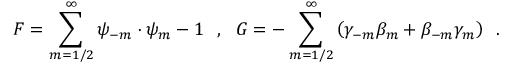<formula> <loc_0><loc_0><loc_500><loc_500>{ F } = { \sum _ { m = 1 / 2 } ^ { \infty } \psi _ { - m } \cdot \psi _ { m } } - 1 , { G } = { - \sum _ { m = 1 / 2 } ^ { \infty } \left ( \gamma _ { - m } \beta _ { m } + \beta _ { - m } \gamma _ { m } \right ) } .</formula> 